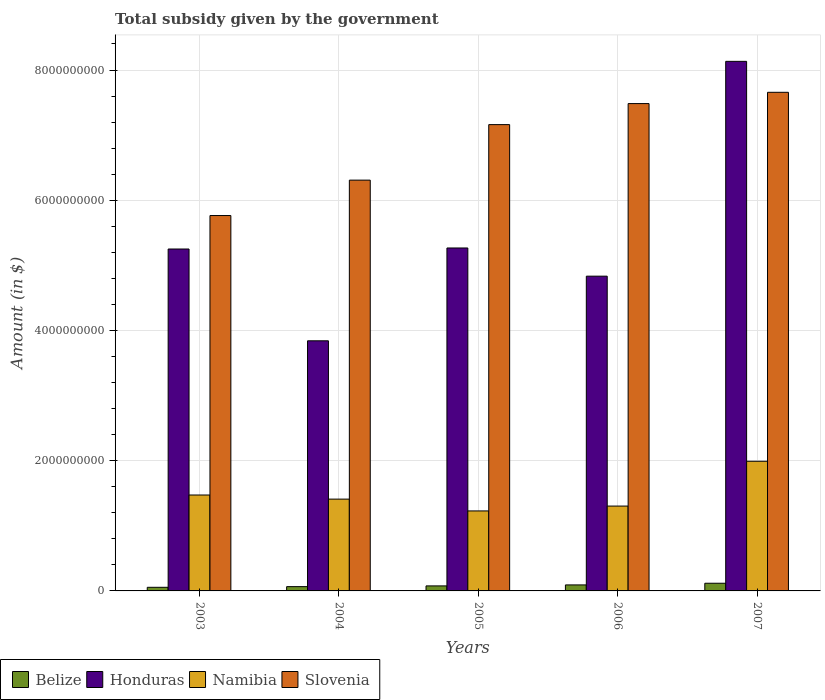Are the number of bars per tick equal to the number of legend labels?
Keep it short and to the point. Yes. How many bars are there on the 2nd tick from the left?
Offer a very short reply. 4. What is the label of the 5th group of bars from the left?
Your answer should be compact. 2007. What is the total revenue collected by the government in Honduras in 2003?
Provide a succinct answer. 5.25e+09. Across all years, what is the maximum total revenue collected by the government in Honduras?
Your answer should be compact. 8.13e+09. Across all years, what is the minimum total revenue collected by the government in Honduras?
Provide a short and direct response. 3.84e+09. In which year was the total revenue collected by the government in Namibia minimum?
Give a very brief answer. 2005. What is the total total revenue collected by the government in Namibia in the graph?
Your answer should be compact. 7.41e+09. What is the difference between the total revenue collected by the government in Slovenia in 2006 and that in 2007?
Provide a short and direct response. -1.73e+08. What is the difference between the total revenue collected by the government in Namibia in 2003 and the total revenue collected by the government in Slovenia in 2004?
Keep it short and to the point. -4.84e+09. What is the average total revenue collected by the government in Honduras per year?
Your answer should be compact. 5.47e+09. In the year 2007, what is the difference between the total revenue collected by the government in Honduras and total revenue collected by the government in Slovenia?
Offer a very short reply. 4.75e+08. In how many years, is the total revenue collected by the government in Honduras greater than 2800000000 $?
Your response must be concise. 5. What is the ratio of the total revenue collected by the government in Honduras in 2003 to that in 2007?
Offer a terse response. 0.65. Is the difference between the total revenue collected by the government in Honduras in 2003 and 2004 greater than the difference between the total revenue collected by the government in Slovenia in 2003 and 2004?
Your response must be concise. Yes. What is the difference between the highest and the second highest total revenue collected by the government in Slovenia?
Provide a short and direct response. 1.73e+08. What is the difference between the highest and the lowest total revenue collected by the government in Belize?
Offer a very short reply. 6.25e+07. In how many years, is the total revenue collected by the government in Namibia greater than the average total revenue collected by the government in Namibia taken over all years?
Offer a very short reply. 1. Is it the case that in every year, the sum of the total revenue collected by the government in Belize and total revenue collected by the government in Namibia is greater than the sum of total revenue collected by the government in Honduras and total revenue collected by the government in Slovenia?
Your response must be concise. No. What does the 2nd bar from the left in 2006 represents?
Your answer should be very brief. Honduras. What does the 2nd bar from the right in 2007 represents?
Ensure brevity in your answer.  Namibia. Is it the case that in every year, the sum of the total revenue collected by the government in Belize and total revenue collected by the government in Namibia is greater than the total revenue collected by the government in Slovenia?
Provide a short and direct response. No. How many bars are there?
Your response must be concise. 20. Are all the bars in the graph horizontal?
Offer a terse response. No. Are the values on the major ticks of Y-axis written in scientific E-notation?
Give a very brief answer. No. Does the graph contain grids?
Give a very brief answer. Yes. Where does the legend appear in the graph?
Provide a succinct answer. Bottom left. How many legend labels are there?
Make the answer very short. 4. What is the title of the graph?
Your answer should be compact. Total subsidy given by the government. Does "Kyrgyz Republic" appear as one of the legend labels in the graph?
Give a very brief answer. No. What is the label or title of the Y-axis?
Offer a terse response. Amount (in $). What is the Amount (in $) of Belize in 2003?
Make the answer very short. 5.55e+07. What is the Amount (in $) in Honduras in 2003?
Your answer should be very brief. 5.25e+09. What is the Amount (in $) in Namibia in 2003?
Provide a short and direct response. 1.47e+09. What is the Amount (in $) in Slovenia in 2003?
Ensure brevity in your answer.  5.77e+09. What is the Amount (in $) in Belize in 2004?
Make the answer very short. 6.60e+07. What is the Amount (in $) in Honduras in 2004?
Offer a terse response. 3.84e+09. What is the Amount (in $) of Namibia in 2004?
Keep it short and to the point. 1.41e+09. What is the Amount (in $) in Slovenia in 2004?
Offer a terse response. 6.31e+09. What is the Amount (in $) in Belize in 2005?
Give a very brief answer. 7.71e+07. What is the Amount (in $) of Honduras in 2005?
Make the answer very short. 5.27e+09. What is the Amount (in $) in Namibia in 2005?
Provide a short and direct response. 1.23e+09. What is the Amount (in $) in Slovenia in 2005?
Your response must be concise. 7.16e+09. What is the Amount (in $) in Belize in 2006?
Your answer should be very brief. 9.24e+07. What is the Amount (in $) of Honduras in 2006?
Give a very brief answer. 4.83e+09. What is the Amount (in $) in Namibia in 2006?
Ensure brevity in your answer.  1.30e+09. What is the Amount (in $) of Slovenia in 2006?
Keep it short and to the point. 7.48e+09. What is the Amount (in $) in Belize in 2007?
Provide a succinct answer. 1.18e+08. What is the Amount (in $) of Honduras in 2007?
Your answer should be very brief. 8.13e+09. What is the Amount (in $) in Namibia in 2007?
Offer a very short reply. 1.99e+09. What is the Amount (in $) in Slovenia in 2007?
Your answer should be very brief. 7.66e+09. Across all years, what is the maximum Amount (in $) of Belize?
Your response must be concise. 1.18e+08. Across all years, what is the maximum Amount (in $) of Honduras?
Make the answer very short. 8.13e+09. Across all years, what is the maximum Amount (in $) of Namibia?
Your response must be concise. 1.99e+09. Across all years, what is the maximum Amount (in $) in Slovenia?
Your response must be concise. 7.66e+09. Across all years, what is the minimum Amount (in $) of Belize?
Provide a short and direct response. 5.55e+07. Across all years, what is the minimum Amount (in $) of Honduras?
Keep it short and to the point. 3.84e+09. Across all years, what is the minimum Amount (in $) of Namibia?
Offer a terse response. 1.23e+09. Across all years, what is the minimum Amount (in $) in Slovenia?
Provide a short and direct response. 5.77e+09. What is the total Amount (in $) of Belize in the graph?
Make the answer very short. 4.09e+08. What is the total Amount (in $) in Honduras in the graph?
Your answer should be very brief. 2.73e+1. What is the total Amount (in $) of Namibia in the graph?
Offer a very short reply. 7.41e+09. What is the total Amount (in $) in Slovenia in the graph?
Your response must be concise. 3.44e+1. What is the difference between the Amount (in $) of Belize in 2003 and that in 2004?
Ensure brevity in your answer.  -1.04e+07. What is the difference between the Amount (in $) in Honduras in 2003 and that in 2004?
Give a very brief answer. 1.41e+09. What is the difference between the Amount (in $) of Namibia in 2003 and that in 2004?
Your answer should be compact. 6.31e+07. What is the difference between the Amount (in $) of Slovenia in 2003 and that in 2004?
Your answer should be very brief. -5.44e+08. What is the difference between the Amount (in $) in Belize in 2003 and that in 2005?
Offer a terse response. -2.15e+07. What is the difference between the Amount (in $) in Honduras in 2003 and that in 2005?
Offer a terse response. -1.57e+07. What is the difference between the Amount (in $) of Namibia in 2003 and that in 2005?
Provide a succinct answer. 2.44e+08. What is the difference between the Amount (in $) of Slovenia in 2003 and that in 2005?
Ensure brevity in your answer.  -1.40e+09. What is the difference between the Amount (in $) of Belize in 2003 and that in 2006?
Keep it short and to the point. -3.68e+07. What is the difference between the Amount (in $) in Honduras in 2003 and that in 2006?
Offer a very short reply. 4.17e+08. What is the difference between the Amount (in $) of Namibia in 2003 and that in 2006?
Your answer should be compact. 1.70e+08. What is the difference between the Amount (in $) of Slovenia in 2003 and that in 2006?
Give a very brief answer. -1.72e+09. What is the difference between the Amount (in $) of Belize in 2003 and that in 2007?
Provide a short and direct response. -6.25e+07. What is the difference between the Amount (in $) of Honduras in 2003 and that in 2007?
Ensure brevity in your answer.  -2.88e+09. What is the difference between the Amount (in $) in Namibia in 2003 and that in 2007?
Provide a short and direct response. -5.18e+08. What is the difference between the Amount (in $) of Slovenia in 2003 and that in 2007?
Give a very brief answer. -1.89e+09. What is the difference between the Amount (in $) in Belize in 2004 and that in 2005?
Provide a succinct answer. -1.11e+07. What is the difference between the Amount (in $) in Honduras in 2004 and that in 2005?
Your answer should be very brief. -1.43e+09. What is the difference between the Amount (in $) of Namibia in 2004 and that in 2005?
Ensure brevity in your answer.  1.81e+08. What is the difference between the Amount (in $) of Slovenia in 2004 and that in 2005?
Offer a very short reply. -8.53e+08. What is the difference between the Amount (in $) in Belize in 2004 and that in 2006?
Your response must be concise. -2.64e+07. What is the difference between the Amount (in $) of Honduras in 2004 and that in 2006?
Your answer should be very brief. -9.93e+08. What is the difference between the Amount (in $) of Namibia in 2004 and that in 2006?
Keep it short and to the point. 1.07e+08. What is the difference between the Amount (in $) of Slovenia in 2004 and that in 2006?
Make the answer very short. -1.18e+09. What is the difference between the Amount (in $) in Belize in 2004 and that in 2007?
Your response must be concise. -5.20e+07. What is the difference between the Amount (in $) in Honduras in 2004 and that in 2007?
Give a very brief answer. -4.29e+09. What is the difference between the Amount (in $) in Namibia in 2004 and that in 2007?
Ensure brevity in your answer.  -5.81e+08. What is the difference between the Amount (in $) of Slovenia in 2004 and that in 2007?
Offer a very short reply. -1.35e+09. What is the difference between the Amount (in $) of Belize in 2005 and that in 2006?
Your answer should be compact. -1.53e+07. What is the difference between the Amount (in $) in Honduras in 2005 and that in 2006?
Offer a very short reply. 4.33e+08. What is the difference between the Amount (in $) of Namibia in 2005 and that in 2006?
Your answer should be very brief. -7.44e+07. What is the difference between the Amount (in $) of Slovenia in 2005 and that in 2006?
Make the answer very short. -3.23e+08. What is the difference between the Amount (in $) in Belize in 2005 and that in 2007?
Your response must be concise. -4.09e+07. What is the difference between the Amount (in $) of Honduras in 2005 and that in 2007?
Offer a terse response. -2.87e+09. What is the difference between the Amount (in $) in Namibia in 2005 and that in 2007?
Make the answer very short. -7.63e+08. What is the difference between the Amount (in $) in Slovenia in 2005 and that in 2007?
Your answer should be compact. -4.96e+08. What is the difference between the Amount (in $) in Belize in 2006 and that in 2007?
Ensure brevity in your answer.  -2.56e+07. What is the difference between the Amount (in $) in Honduras in 2006 and that in 2007?
Offer a terse response. -3.30e+09. What is the difference between the Amount (in $) of Namibia in 2006 and that in 2007?
Your response must be concise. -6.88e+08. What is the difference between the Amount (in $) of Slovenia in 2006 and that in 2007?
Keep it short and to the point. -1.73e+08. What is the difference between the Amount (in $) of Belize in 2003 and the Amount (in $) of Honduras in 2004?
Your answer should be compact. -3.79e+09. What is the difference between the Amount (in $) of Belize in 2003 and the Amount (in $) of Namibia in 2004?
Your response must be concise. -1.35e+09. What is the difference between the Amount (in $) in Belize in 2003 and the Amount (in $) in Slovenia in 2004?
Give a very brief answer. -6.25e+09. What is the difference between the Amount (in $) in Honduras in 2003 and the Amount (in $) in Namibia in 2004?
Your answer should be very brief. 3.84e+09. What is the difference between the Amount (in $) in Honduras in 2003 and the Amount (in $) in Slovenia in 2004?
Provide a short and direct response. -1.06e+09. What is the difference between the Amount (in $) in Namibia in 2003 and the Amount (in $) in Slovenia in 2004?
Provide a short and direct response. -4.84e+09. What is the difference between the Amount (in $) in Belize in 2003 and the Amount (in $) in Honduras in 2005?
Give a very brief answer. -5.21e+09. What is the difference between the Amount (in $) in Belize in 2003 and the Amount (in $) in Namibia in 2005?
Keep it short and to the point. -1.17e+09. What is the difference between the Amount (in $) of Belize in 2003 and the Amount (in $) of Slovenia in 2005?
Keep it short and to the point. -7.11e+09. What is the difference between the Amount (in $) of Honduras in 2003 and the Amount (in $) of Namibia in 2005?
Provide a succinct answer. 4.02e+09. What is the difference between the Amount (in $) in Honduras in 2003 and the Amount (in $) in Slovenia in 2005?
Offer a terse response. -1.91e+09. What is the difference between the Amount (in $) in Namibia in 2003 and the Amount (in $) in Slovenia in 2005?
Offer a terse response. -5.69e+09. What is the difference between the Amount (in $) in Belize in 2003 and the Amount (in $) in Honduras in 2006?
Provide a short and direct response. -4.78e+09. What is the difference between the Amount (in $) in Belize in 2003 and the Amount (in $) in Namibia in 2006?
Keep it short and to the point. -1.25e+09. What is the difference between the Amount (in $) of Belize in 2003 and the Amount (in $) of Slovenia in 2006?
Ensure brevity in your answer.  -7.43e+09. What is the difference between the Amount (in $) in Honduras in 2003 and the Amount (in $) in Namibia in 2006?
Your answer should be compact. 3.95e+09. What is the difference between the Amount (in $) in Honduras in 2003 and the Amount (in $) in Slovenia in 2006?
Make the answer very short. -2.23e+09. What is the difference between the Amount (in $) in Namibia in 2003 and the Amount (in $) in Slovenia in 2006?
Your response must be concise. -6.01e+09. What is the difference between the Amount (in $) of Belize in 2003 and the Amount (in $) of Honduras in 2007?
Keep it short and to the point. -8.08e+09. What is the difference between the Amount (in $) in Belize in 2003 and the Amount (in $) in Namibia in 2007?
Your answer should be compact. -1.94e+09. What is the difference between the Amount (in $) in Belize in 2003 and the Amount (in $) in Slovenia in 2007?
Ensure brevity in your answer.  -7.60e+09. What is the difference between the Amount (in $) of Honduras in 2003 and the Amount (in $) of Namibia in 2007?
Offer a terse response. 3.26e+09. What is the difference between the Amount (in $) in Honduras in 2003 and the Amount (in $) in Slovenia in 2007?
Your response must be concise. -2.41e+09. What is the difference between the Amount (in $) of Namibia in 2003 and the Amount (in $) of Slovenia in 2007?
Ensure brevity in your answer.  -6.18e+09. What is the difference between the Amount (in $) of Belize in 2004 and the Amount (in $) of Honduras in 2005?
Keep it short and to the point. -5.20e+09. What is the difference between the Amount (in $) in Belize in 2004 and the Amount (in $) in Namibia in 2005?
Your answer should be compact. -1.16e+09. What is the difference between the Amount (in $) of Belize in 2004 and the Amount (in $) of Slovenia in 2005?
Offer a very short reply. -7.10e+09. What is the difference between the Amount (in $) in Honduras in 2004 and the Amount (in $) in Namibia in 2005?
Give a very brief answer. 2.61e+09. What is the difference between the Amount (in $) of Honduras in 2004 and the Amount (in $) of Slovenia in 2005?
Your answer should be very brief. -3.32e+09. What is the difference between the Amount (in $) in Namibia in 2004 and the Amount (in $) in Slovenia in 2005?
Provide a succinct answer. -5.75e+09. What is the difference between the Amount (in $) of Belize in 2004 and the Amount (in $) of Honduras in 2006?
Your answer should be compact. -4.77e+09. What is the difference between the Amount (in $) of Belize in 2004 and the Amount (in $) of Namibia in 2006?
Provide a succinct answer. -1.24e+09. What is the difference between the Amount (in $) of Belize in 2004 and the Amount (in $) of Slovenia in 2006?
Provide a short and direct response. -7.42e+09. What is the difference between the Amount (in $) of Honduras in 2004 and the Amount (in $) of Namibia in 2006?
Ensure brevity in your answer.  2.54e+09. What is the difference between the Amount (in $) of Honduras in 2004 and the Amount (in $) of Slovenia in 2006?
Offer a very short reply. -3.64e+09. What is the difference between the Amount (in $) of Namibia in 2004 and the Amount (in $) of Slovenia in 2006?
Your answer should be compact. -6.07e+09. What is the difference between the Amount (in $) of Belize in 2004 and the Amount (in $) of Honduras in 2007?
Your answer should be compact. -8.07e+09. What is the difference between the Amount (in $) in Belize in 2004 and the Amount (in $) in Namibia in 2007?
Your answer should be compact. -1.93e+09. What is the difference between the Amount (in $) of Belize in 2004 and the Amount (in $) of Slovenia in 2007?
Your response must be concise. -7.59e+09. What is the difference between the Amount (in $) of Honduras in 2004 and the Amount (in $) of Namibia in 2007?
Make the answer very short. 1.85e+09. What is the difference between the Amount (in $) in Honduras in 2004 and the Amount (in $) in Slovenia in 2007?
Offer a very short reply. -3.82e+09. What is the difference between the Amount (in $) of Namibia in 2004 and the Amount (in $) of Slovenia in 2007?
Ensure brevity in your answer.  -6.25e+09. What is the difference between the Amount (in $) of Belize in 2005 and the Amount (in $) of Honduras in 2006?
Your answer should be compact. -4.76e+09. What is the difference between the Amount (in $) of Belize in 2005 and the Amount (in $) of Namibia in 2006?
Keep it short and to the point. -1.23e+09. What is the difference between the Amount (in $) in Belize in 2005 and the Amount (in $) in Slovenia in 2006?
Offer a very short reply. -7.41e+09. What is the difference between the Amount (in $) of Honduras in 2005 and the Amount (in $) of Namibia in 2006?
Your answer should be compact. 3.96e+09. What is the difference between the Amount (in $) of Honduras in 2005 and the Amount (in $) of Slovenia in 2006?
Keep it short and to the point. -2.22e+09. What is the difference between the Amount (in $) of Namibia in 2005 and the Amount (in $) of Slovenia in 2006?
Keep it short and to the point. -6.26e+09. What is the difference between the Amount (in $) in Belize in 2005 and the Amount (in $) in Honduras in 2007?
Make the answer very short. -8.06e+09. What is the difference between the Amount (in $) of Belize in 2005 and the Amount (in $) of Namibia in 2007?
Your answer should be very brief. -1.91e+09. What is the difference between the Amount (in $) in Belize in 2005 and the Amount (in $) in Slovenia in 2007?
Keep it short and to the point. -7.58e+09. What is the difference between the Amount (in $) of Honduras in 2005 and the Amount (in $) of Namibia in 2007?
Give a very brief answer. 3.28e+09. What is the difference between the Amount (in $) of Honduras in 2005 and the Amount (in $) of Slovenia in 2007?
Your answer should be compact. -2.39e+09. What is the difference between the Amount (in $) in Namibia in 2005 and the Amount (in $) in Slovenia in 2007?
Your response must be concise. -6.43e+09. What is the difference between the Amount (in $) of Belize in 2006 and the Amount (in $) of Honduras in 2007?
Give a very brief answer. -8.04e+09. What is the difference between the Amount (in $) in Belize in 2006 and the Amount (in $) in Namibia in 2007?
Your answer should be compact. -1.90e+09. What is the difference between the Amount (in $) in Belize in 2006 and the Amount (in $) in Slovenia in 2007?
Ensure brevity in your answer.  -7.57e+09. What is the difference between the Amount (in $) in Honduras in 2006 and the Amount (in $) in Namibia in 2007?
Ensure brevity in your answer.  2.84e+09. What is the difference between the Amount (in $) in Honduras in 2006 and the Amount (in $) in Slovenia in 2007?
Make the answer very short. -2.82e+09. What is the difference between the Amount (in $) of Namibia in 2006 and the Amount (in $) of Slovenia in 2007?
Ensure brevity in your answer.  -6.35e+09. What is the average Amount (in $) in Belize per year?
Provide a short and direct response. 8.18e+07. What is the average Amount (in $) in Honduras per year?
Provide a short and direct response. 5.47e+09. What is the average Amount (in $) in Namibia per year?
Your answer should be compact. 1.48e+09. What is the average Amount (in $) in Slovenia per year?
Provide a short and direct response. 6.88e+09. In the year 2003, what is the difference between the Amount (in $) of Belize and Amount (in $) of Honduras?
Ensure brevity in your answer.  -5.20e+09. In the year 2003, what is the difference between the Amount (in $) of Belize and Amount (in $) of Namibia?
Make the answer very short. -1.42e+09. In the year 2003, what is the difference between the Amount (in $) in Belize and Amount (in $) in Slovenia?
Give a very brief answer. -5.71e+09. In the year 2003, what is the difference between the Amount (in $) in Honduras and Amount (in $) in Namibia?
Your answer should be very brief. 3.78e+09. In the year 2003, what is the difference between the Amount (in $) in Honduras and Amount (in $) in Slovenia?
Provide a short and direct response. -5.14e+08. In the year 2003, what is the difference between the Amount (in $) of Namibia and Amount (in $) of Slovenia?
Make the answer very short. -4.29e+09. In the year 2004, what is the difference between the Amount (in $) of Belize and Amount (in $) of Honduras?
Offer a very short reply. -3.78e+09. In the year 2004, what is the difference between the Amount (in $) of Belize and Amount (in $) of Namibia?
Offer a terse response. -1.34e+09. In the year 2004, what is the difference between the Amount (in $) of Belize and Amount (in $) of Slovenia?
Provide a succinct answer. -6.24e+09. In the year 2004, what is the difference between the Amount (in $) in Honduras and Amount (in $) in Namibia?
Your answer should be compact. 2.43e+09. In the year 2004, what is the difference between the Amount (in $) in Honduras and Amount (in $) in Slovenia?
Your response must be concise. -2.47e+09. In the year 2004, what is the difference between the Amount (in $) of Namibia and Amount (in $) of Slovenia?
Make the answer very short. -4.90e+09. In the year 2005, what is the difference between the Amount (in $) of Belize and Amount (in $) of Honduras?
Provide a succinct answer. -5.19e+09. In the year 2005, what is the difference between the Amount (in $) of Belize and Amount (in $) of Namibia?
Your answer should be very brief. -1.15e+09. In the year 2005, what is the difference between the Amount (in $) of Belize and Amount (in $) of Slovenia?
Make the answer very short. -7.08e+09. In the year 2005, what is the difference between the Amount (in $) in Honduras and Amount (in $) in Namibia?
Your answer should be compact. 4.04e+09. In the year 2005, what is the difference between the Amount (in $) of Honduras and Amount (in $) of Slovenia?
Provide a short and direct response. -1.89e+09. In the year 2005, what is the difference between the Amount (in $) in Namibia and Amount (in $) in Slovenia?
Your answer should be very brief. -5.93e+09. In the year 2006, what is the difference between the Amount (in $) of Belize and Amount (in $) of Honduras?
Make the answer very short. -4.74e+09. In the year 2006, what is the difference between the Amount (in $) in Belize and Amount (in $) in Namibia?
Ensure brevity in your answer.  -1.21e+09. In the year 2006, what is the difference between the Amount (in $) of Belize and Amount (in $) of Slovenia?
Keep it short and to the point. -7.39e+09. In the year 2006, what is the difference between the Amount (in $) in Honduras and Amount (in $) in Namibia?
Provide a short and direct response. 3.53e+09. In the year 2006, what is the difference between the Amount (in $) of Honduras and Amount (in $) of Slovenia?
Provide a succinct answer. -2.65e+09. In the year 2006, what is the difference between the Amount (in $) of Namibia and Amount (in $) of Slovenia?
Offer a very short reply. -6.18e+09. In the year 2007, what is the difference between the Amount (in $) of Belize and Amount (in $) of Honduras?
Provide a succinct answer. -8.01e+09. In the year 2007, what is the difference between the Amount (in $) of Belize and Amount (in $) of Namibia?
Keep it short and to the point. -1.87e+09. In the year 2007, what is the difference between the Amount (in $) in Belize and Amount (in $) in Slovenia?
Provide a short and direct response. -7.54e+09. In the year 2007, what is the difference between the Amount (in $) of Honduras and Amount (in $) of Namibia?
Provide a short and direct response. 6.14e+09. In the year 2007, what is the difference between the Amount (in $) in Honduras and Amount (in $) in Slovenia?
Your answer should be very brief. 4.75e+08. In the year 2007, what is the difference between the Amount (in $) in Namibia and Amount (in $) in Slovenia?
Keep it short and to the point. -5.67e+09. What is the ratio of the Amount (in $) in Belize in 2003 to that in 2004?
Keep it short and to the point. 0.84. What is the ratio of the Amount (in $) in Honduras in 2003 to that in 2004?
Provide a short and direct response. 1.37. What is the ratio of the Amount (in $) of Namibia in 2003 to that in 2004?
Give a very brief answer. 1.04. What is the ratio of the Amount (in $) in Slovenia in 2003 to that in 2004?
Offer a terse response. 0.91. What is the ratio of the Amount (in $) in Belize in 2003 to that in 2005?
Make the answer very short. 0.72. What is the ratio of the Amount (in $) of Honduras in 2003 to that in 2005?
Your answer should be compact. 1. What is the ratio of the Amount (in $) in Namibia in 2003 to that in 2005?
Make the answer very short. 1.2. What is the ratio of the Amount (in $) in Slovenia in 2003 to that in 2005?
Ensure brevity in your answer.  0.81. What is the ratio of the Amount (in $) in Belize in 2003 to that in 2006?
Ensure brevity in your answer.  0.6. What is the ratio of the Amount (in $) in Honduras in 2003 to that in 2006?
Keep it short and to the point. 1.09. What is the ratio of the Amount (in $) in Namibia in 2003 to that in 2006?
Keep it short and to the point. 1.13. What is the ratio of the Amount (in $) in Slovenia in 2003 to that in 2006?
Give a very brief answer. 0.77. What is the ratio of the Amount (in $) of Belize in 2003 to that in 2007?
Your answer should be compact. 0.47. What is the ratio of the Amount (in $) in Honduras in 2003 to that in 2007?
Offer a terse response. 0.65. What is the ratio of the Amount (in $) in Namibia in 2003 to that in 2007?
Offer a very short reply. 0.74. What is the ratio of the Amount (in $) in Slovenia in 2003 to that in 2007?
Make the answer very short. 0.75. What is the ratio of the Amount (in $) of Belize in 2004 to that in 2005?
Keep it short and to the point. 0.86. What is the ratio of the Amount (in $) of Honduras in 2004 to that in 2005?
Offer a terse response. 0.73. What is the ratio of the Amount (in $) of Namibia in 2004 to that in 2005?
Your answer should be compact. 1.15. What is the ratio of the Amount (in $) of Slovenia in 2004 to that in 2005?
Make the answer very short. 0.88. What is the ratio of the Amount (in $) in Belize in 2004 to that in 2006?
Your response must be concise. 0.71. What is the ratio of the Amount (in $) of Honduras in 2004 to that in 2006?
Offer a very short reply. 0.79. What is the ratio of the Amount (in $) in Namibia in 2004 to that in 2006?
Your answer should be compact. 1.08. What is the ratio of the Amount (in $) in Slovenia in 2004 to that in 2006?
Offer a very short reply. 0.84. What is the ratio of the Amount (in $) of Belize in 2004 to that in 2007?
Your answer should be very brief. 0.56. What is the ratio of the Amount (in $) of Honduras in 2004 to that in 2007?
Provide a short and direct response. 0.47. What is the ratio of the Amount (in $) of Namibia in 2004 to that in 2007?
Your response must be concise. 0.71. What is the ratio of the Amount (in $) in Slovenia in 2004 to that in 2007?
Keep it short and to the point. 0.82. What is the ratio of the Amount (in $) of Belize in 2005 to that in 2006?
Give a very brief answer. 0.83. What is the ratio of the Amount (in $) of Honduras in 2005 to that in 2006?
Your response must be concise. 1.09. What is the ratio of the Amount (in $) in Namibia in 2005 to that in 2006?
Ensure brevity in your answer.  0.94. What is the ratio of the Amount (in $) in Slovenia in 2005 to that in 2006?
Offer a terse response. 0.96. What is the ratio of the Amount (in $) in Belize in 2005 to that in 2007?
Offer a terse response. 0.65. What is the ratio of the Amount (in $) in Honduras in 2005 to that in 2007?
Offer a terse response. 0.65. What is the ratio of the Amount (in $) in Namibia in 2005 to that in 2007?
Provide a succinct answer. 0.62. What is the ratio of the Amount (in $) in Slovenia in 2005 to that in 2007?
Provide a succinct answer. 0.94. What is the ratio of the Amount (in $) of Belize in 2006 to that in 2007?
Provide a succinct answer. 0.78. What is the ratio of the Amount (in $) in Honduras in 2006 to that in 2007?
Provide a succinct answer. 0.59. What is the ratio of the Amount (in $) of Namibia in 2006 to that in 2007?
Make the answer very short. 0.65. What is the ratio of the Amount (in $) of Slovenia in 2006 to that in 2007?
Make the answer very short. 0.98. What is the difference between the highest and the second highest Amount (in $) in Belize?
Offer a very short reply. 2.56e+07. What is the difference between the highest and the second highest Amount (in $) of Honduras?
Make the answer very short. 2.87e+09. What is the difference between the highest and the second highest Amount (in $) of Namibia?
Provide a succinct answer. 5.18e+08. What is the difference between the highest and the second highest Amount (in $) in Slovenia?
Ensure brevity in your answer.  1.73e+08. What is the difference between the highest and the lowest Amount (in $) in Belize?
Your answer should be compact. 6.25e+07. What is the difference between the highest and the lowest Amount (in $) of Honduras?
Keep it short and to the point. 4.29e+09. What is the difference between the highest and the lowest Amount (in $) in Namibia?
Your response must be concise. 7.63e+08. What is the difference between the highest and the lowest Amount (in $) in Slovenia?
Make the answer very short. 1.89e+09. 